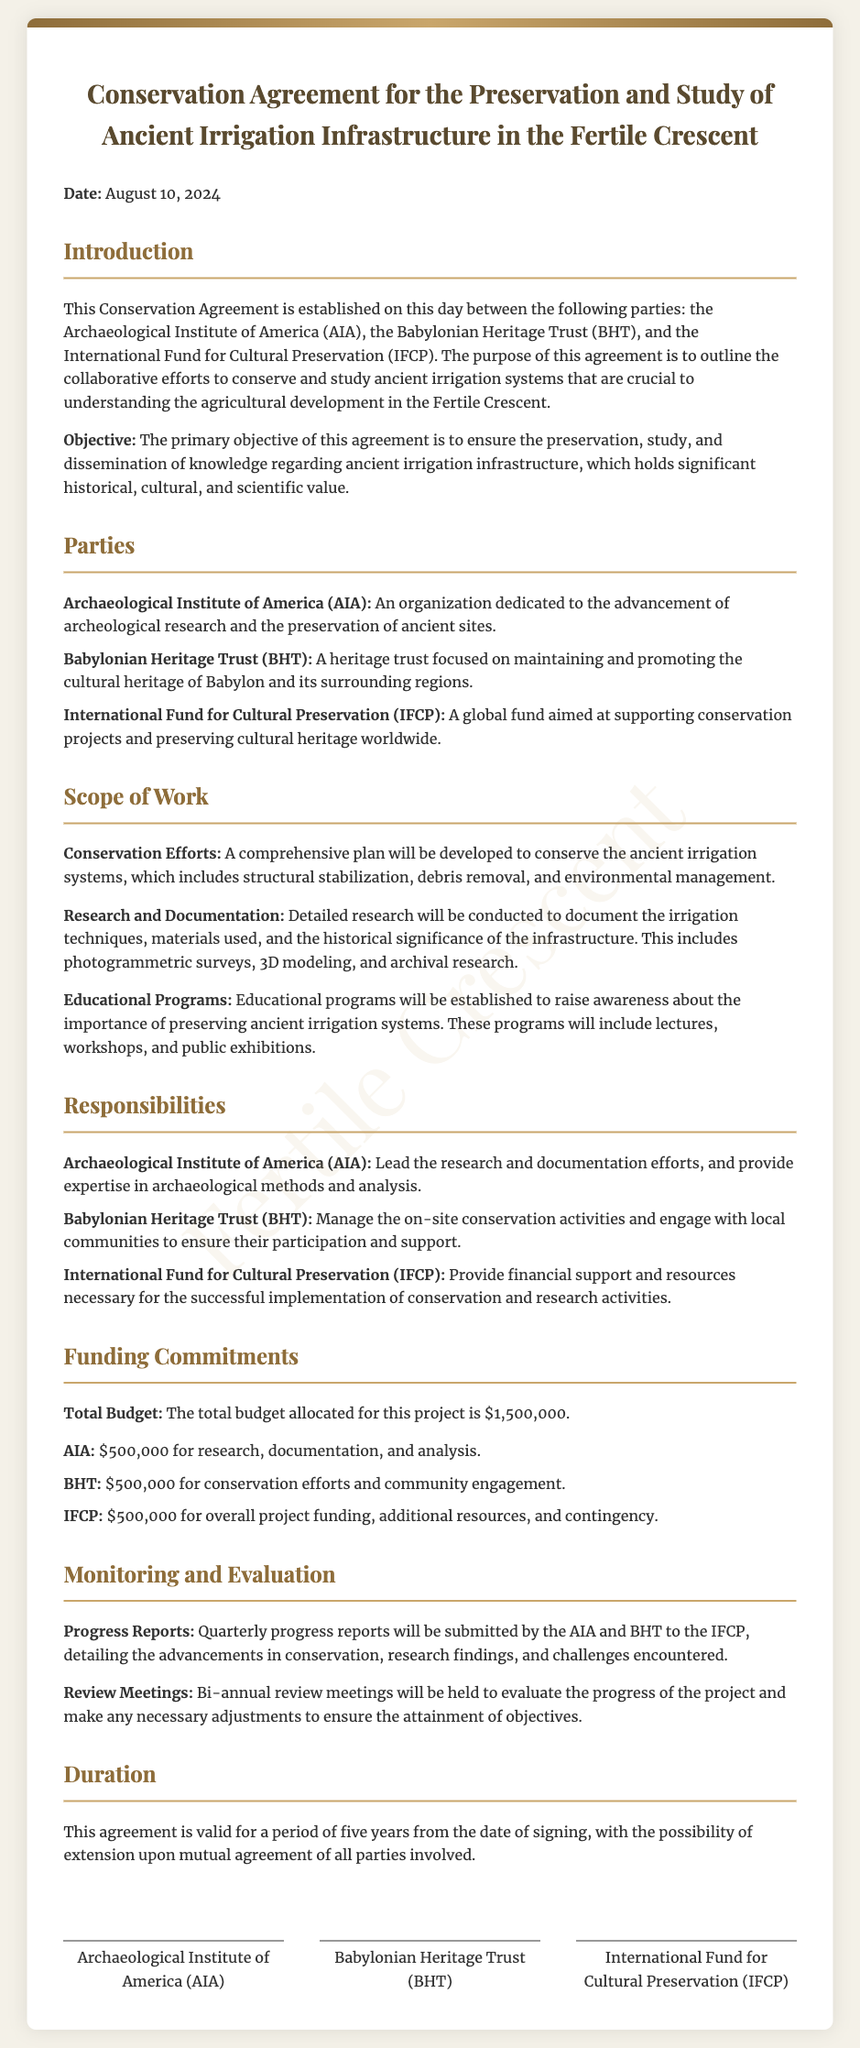What is the total budget allocated for this project? The total budget allocated for this project is specified directly in the document.
Answer: $1,500,000 Who are the parties involved in this agreement? The parties involved are listed in the introduction of the document.
Answer: Archaeological Institute of America (AIA), Babylonian Heritage Trust (BHT), International Fund for Cultural Preservation (IFCP) What is the duration of the agreement? The duration of the agreement is mentioned towards the end of the document.
Answer: Five years What is the responsibility of the AIA? The responsibilities are detailed in the section dedicated to each party's roles.
Answer: Lead the research and documentation efforts How much funding is allocated for conservation efforts by BHT? The exact amount allocated to BHT for conservation efforts is provided in the funding commitments section.
Answer: $500,000 What kind of educational programs will be established? The document specifies the types of initiatives related to education included in the conservation efforts.
Answer: Lectures, workshops, and public exhibitions How often will progress reports be submitted? The frequency of these reports is stated in the monitoring and evaluation section of the document.
Answer: Quarterly What will be done to ensure community engagement? The responsibility of BHT specifies how they will involve the local communities in the conservation efforts.
Answer: Engage with local communities Who provides financial support for the project? Financial support details are outlined under the responsibilities and funding commitments sections, attributing it to one specific party.
Answer: International Fund for Cultural Preservation (IFCP) 